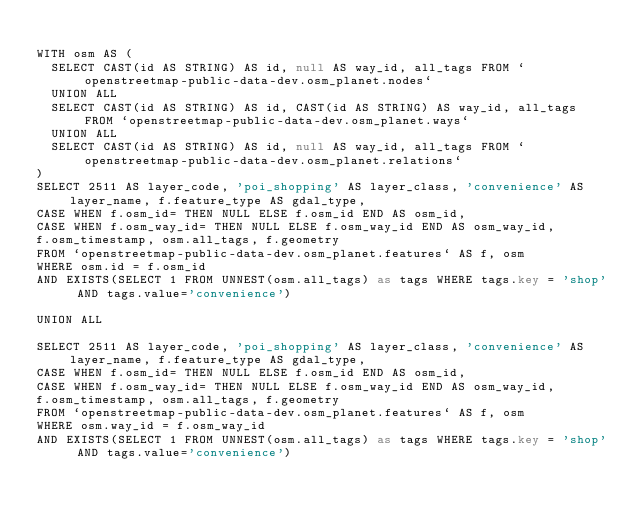<code> <loc_0><loc_0><loc_500><loc_500><_SQL_>
WITH osm AS (
  SELECT CAST(id AS STRING) AS id, null AS way_id, all_tags FROM `openstreetmap-public-data-dev.osm_planet.nodes`
  UNION ALL
  SELECT CAST(id AS STRING) AS id, CAST(id AS STRING) AS way_id, all_tags FROM `openstreetmap-public-data-dev.osm_planet.ways`
  UNION ALL
  SELECT CAST(id AS STRING) AS id, null AS way_id, all_tags FROM `openstreetmap-public-data-dev.osm_planet.relations`
)
SELECT 2511 AS layer_code, 'poi_shopping' AS layer_class, 'convenience' AS layer_name, f.feature_type AS gdal_type,
CASE WHEN f.osm_id= THEN NULL ELSE f.osm_id END AS osm_id,
CASE WHEN f.osm_way_id= THEN NULL ELSE f.osm_way_id END AS osm_way_id,
f.osm_timestamp, osm.all_tags, f.geometry
FROM `openstreetmap-public-data-dev.osm_planet.features` AS f, osm
WHERE osm.id = f.osm_id
AND EXISTS(SELECT 1 FROM UNNEST(osm.all_tags) as tags WHERE tags.key = 'shop' AND tags.value='convenience')

UNION ALL

SELECT 2511 AS layer_code, 'poi_shopping' AS layer_class, 'convenience' AS layer_name, f.feature_type AS gdal_type,
CASE WHEN f.osm_id= THEN NULL ELSE f.osm_id END AS osm_id,
CASE WHEN f.osm_way_id= THEN NULL ELSE f.osm_way_id END AS osm_way_id,
f.osm_timestamp, osm.all_tags, f.geometry
FROM `openstreetmap-public-data-dev.osm_planet.features` AS f, osm
WHERE osm.way_id = f.osm_way_id
AND EXISTS(SELECT 1 FROM UNNEST(osm.all_tags) as tags WHERE tags.key = 'shop' AND tags.value='convenience')

</code> 